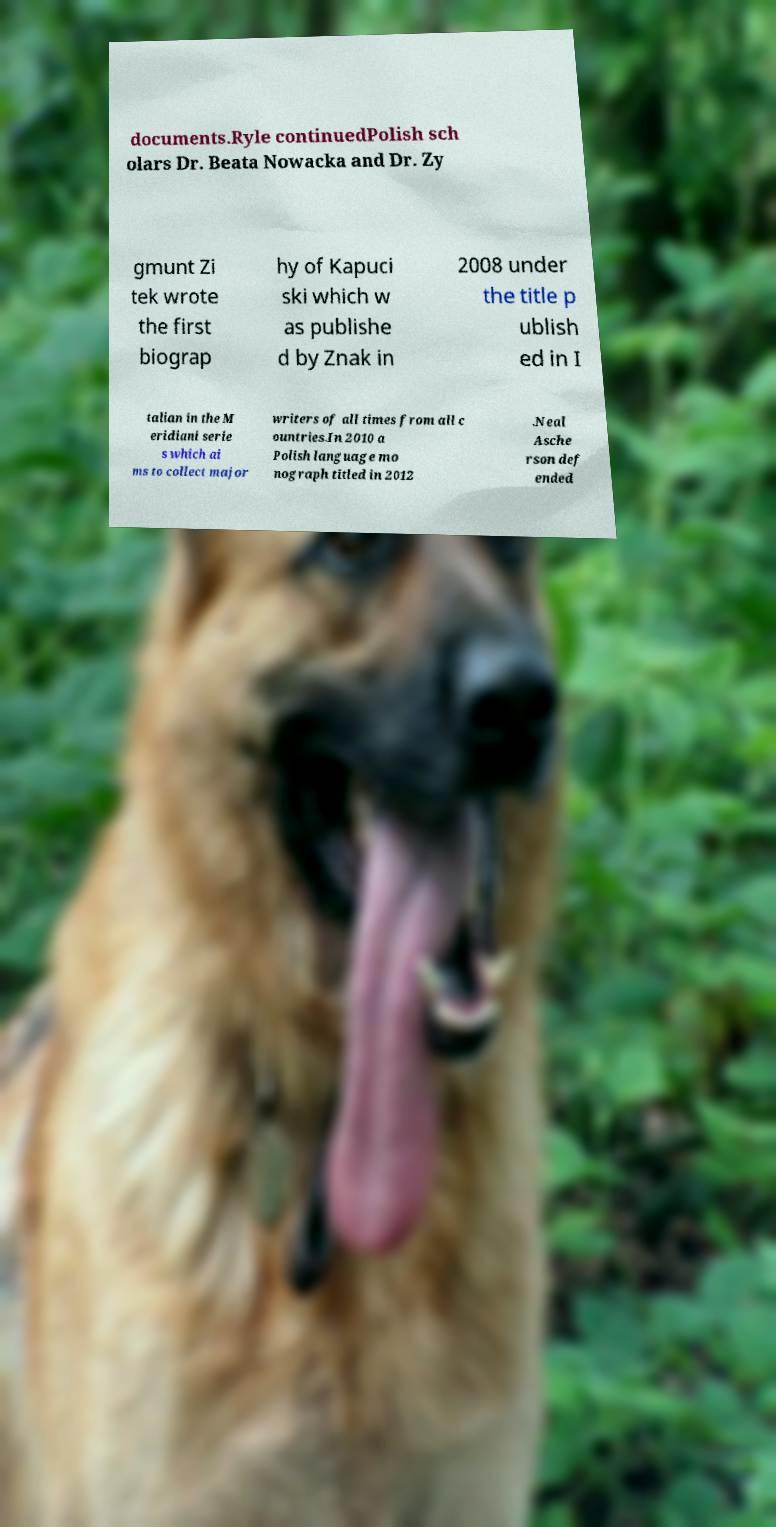Can you read and provide the text displayed in the image?This photo seems to have some interesting text. Can you extract and type it out for me? documents.Ryle continuedPolish sch olars Dr. Beata Nowacka and Dr. Zy gmunt Zi tek wrote the first biograp hy of Kapuci ski which w as publishe d by Znak in 2008 under the title p ublish ed in I talian in the M eridiani serie s which ai ms to collect major writers of all times from all c ountries.In 2010 a Polish language mo nograph titled in 2012 .Neal Asche rson def ended 